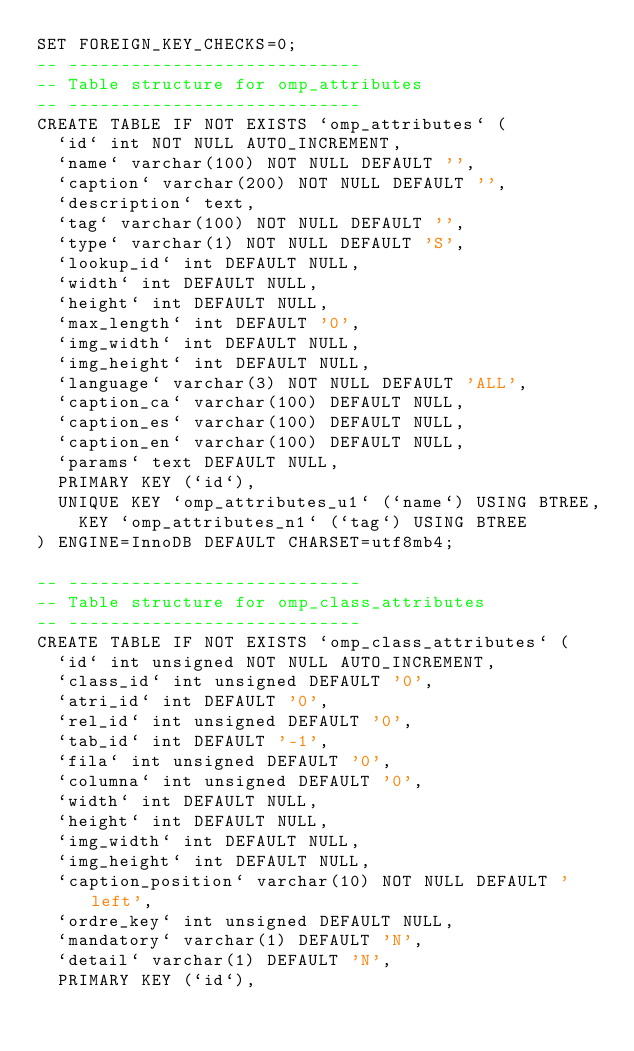Convert code to text. <code><loc_0><loc_0><loc_500><loc_500><_SQL_>SET FOREIGN_KEY_CHECKS=0;
-- ----------------------------
-- Table structure for omp_attributes
-- ----------------------------
CREATE TABLE IF NOT EXISTS `omp_attributes` (
  `id` int NOT NULL AUTO_INCREMENT,
  `name` varchar(100) NOT NULL DEFAULT '',
  `caption` varchar(200) NOT NULL DEFAULT '',
  `description` text,
  `tag` varchar(100) NOT NULL DEFAULT '',
  `type` varchar(1) NOT NULL DEFAULT 'S',
  `lookup_id` int DEFAULT NULL,
  `width` int DEFAULT NULL,
  `height` int DEFAULT NULL,
  `max_length` int DEFAULT '0',
  `img_width` int DEFAULT NULL,
  `img_height` int DEFAULT NULL,
  `language` varchar(3) NOT NULL DEFAULT 'ALL',
  `caption_ca` varchar(100) DEFAULT NULL,
  `caption_es` varchar(100) DEFAULT NULL,
  `caption_en` varchar(100) DEFAULT NULL,
  `params` text DEFAULT NULL,
  PRIMARY KEY (`id`),
  UNIQUE KEY `omp_attributes_u1` (`name`) USING BTREE,
  	KEY `omp_attributes_n1` (`tag`) USING BTREE
) ENGINE=InnoDB DEFAULT CHARSET=utf8mb4;

-- ----------------------------
-- Table structure for omp_class_attributes
-- ----------------------------
CREATE TABLE IF NOT EXISTS `omp_class_attributes` (
  `id` int unsigned NOT NULL AUTO_INCREMENT,
  `class_id` int unsigned DEFAULT '0',
  `atri_id` int DEFAULT '0',
  `rel_id` int unsigned DEFAULT '0',
  `tab_id` int DEFAULT '-1',
  `fila` int unsigned DEFAULT '0',
  `columna` int unsigned DEFAULT '0',
  `width` int DEFAULT NULL,
  `height` int DEFAULT NULL,
  `img_width` int DEFAULT NULL,
  `img_height` int DEFAULT NULL,
  `caption_position` varchar(10) NOT NULL DEFAULT 'left',
  `ordre_key` int unsigned DEFAULT NULL,
  `mandatory` varchar(1) DEFAULT 'N',
  `detail` varchar(1) DEFAULT 'N',
  PRIMARY KEY (`id`),</code> 